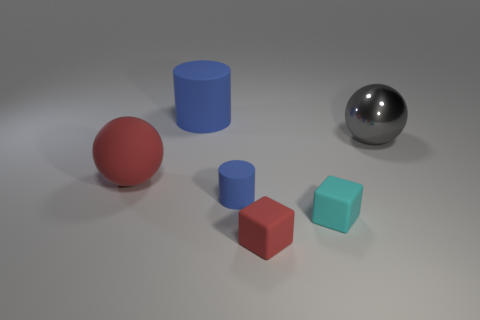What might be the purpose of arranging these objects in this manner? The arrangement appears to be intentionally simplistic and evenly spaced, possibly intended for a study of shapes, perception, or to demonstrate principles of three-dimensional rendering and lighting. 